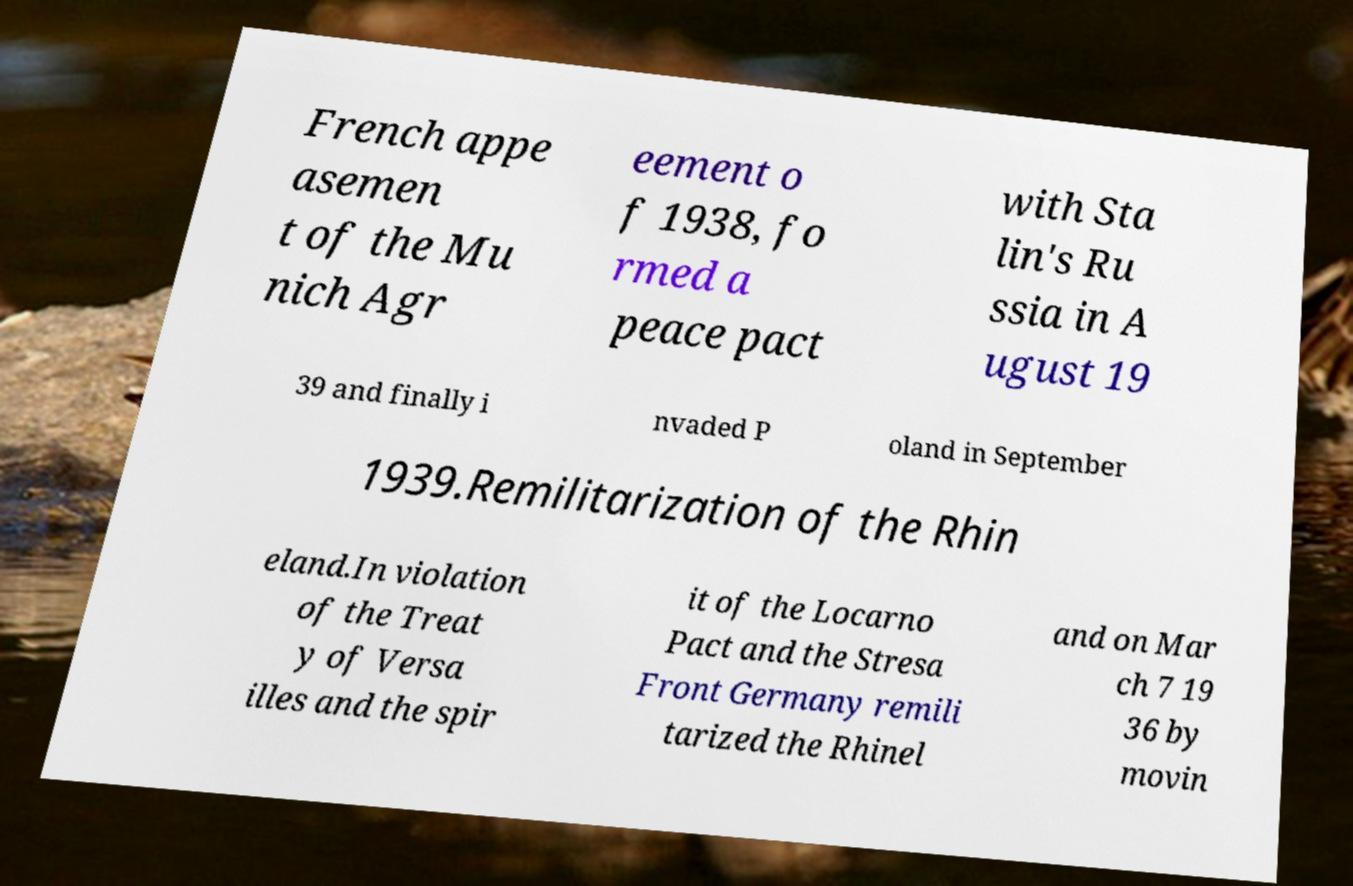What messages or text are displayed in this image? I need them in a readable, typed format. French appe asemen t of the Mu nich Agr eement o f 1938, fo rmed a peace pact with Sta lin's Ru ssia in A ugust 19 39 and finally i nvaded P oland in September 1939.Remilitarization of the Rhin eland.In violation of the Treat y of Versa illes and the spir it of the Locarno Pact and the Stresa Front Germany remili tarized the Rhinel and on Mar ch 7 19 36 by movin 